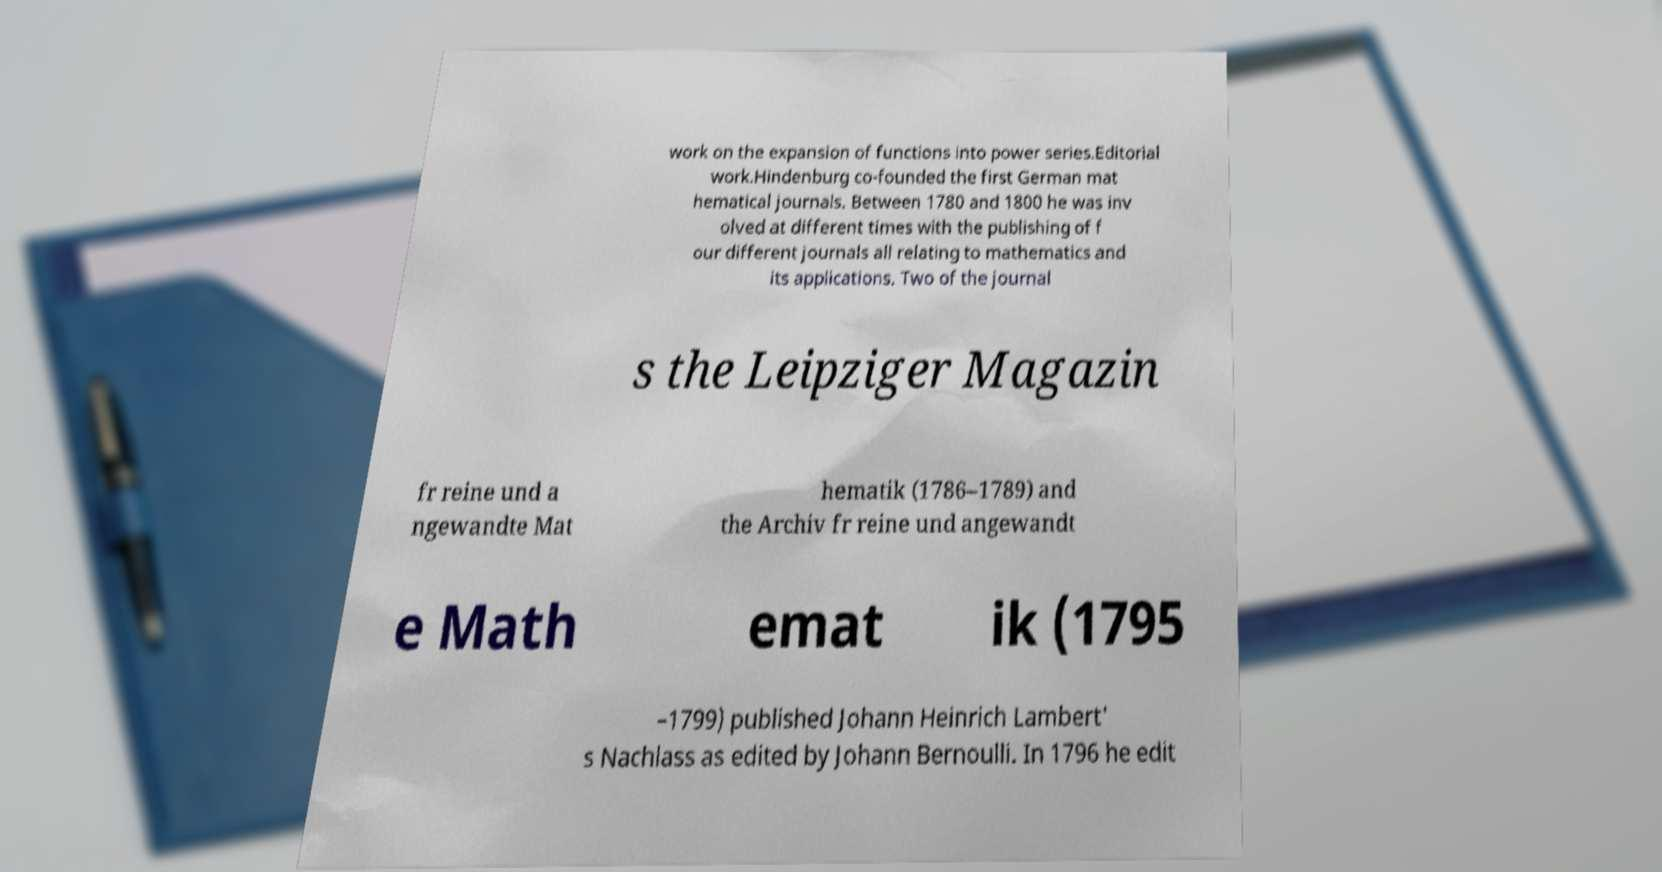Can you read and provide the text displayed in the image?This photo seems to have some interesting text. Can you extract and type it out for me? work on the expansion of functions into power series.Editorial work.Hindenburg co-founded the first German mat hematical journals. Between 1780 and 1800 he was inv olved at different times with the publishing of f our different journals all relating to mathematics and its applications. Two of the journal s the Leipziger Magazin fr reine und a ngewandte Mat hematik (1786–1789) and the Archiv fr reine und angewandt e Math emat ik (1795 –1799) published Johann Heinrich Lambert' s Nachlass as edited by Johann Bernoulli. In 1796 he edit 